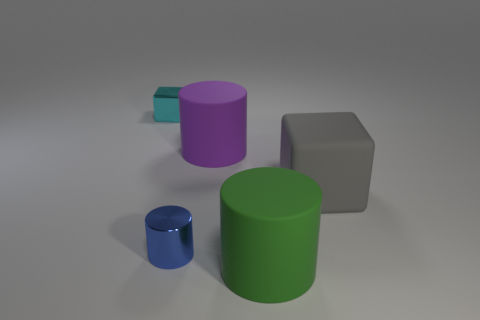What material is the blue thing that is the same size as the cyan object?
Ensure brevity in your answer.  Metal. Do the blue object to the left of the gray matte block and the large gray object have the same size?
Your response must be concise. No. How many big matte cylinders are in front of the matte cylinder that is behind the large matte thing in front of the metal cylinder?
Ensure brevity in your answer.  1. What number of green objects are either large objects or blocks?
Your answer should be compact. 1. What color is the other big cylinder that is made of the same material as the purple cylinder?
Make the answer very short. Green. Is there any other thing that has the same size as the blue metallic object?
Your answer should be very brief. Yes. How many big objects are either green metallic things or blue metallic cylinders?
Your response must be concise. 0. Is the number of gray objects less than the number of small red spheres?
Offer a very short reply. No. What is the color of the other small object that is the same shape as the gray matte object?
Keep it short and to the point. Cyan. Is there any other thing that has the same shape as the large gray matte object?
Your answer should be very brief. Yes. 